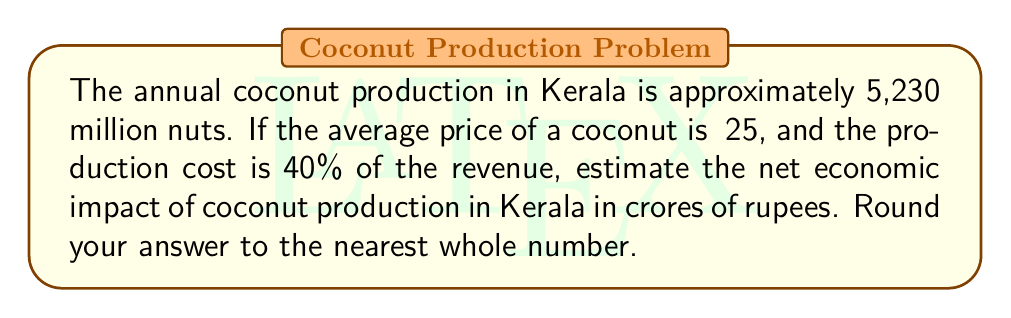Show me your answer to this math problem. Let's approach this problem step-by-step:

1. Calculate the total revenue:
   - Number of coconuts = 5,230 million
   - Price per coconut = ₹25
   - Total revenue = $5,230,000,000 \times ₹25 = ₹130,750,000,000$

2. Calculate the production cost:
   - Production cost is 40% of revenue
   - Production cost = $0.40 \times ₹130,750,000,000 = ₹52,300,000,000$

3. Calculate the net economic impact:
   - Net impact = Total revenue - Production cost
   - Net impact = $₹130,750,000,000 - ₹52,300,000,000 = ₹78,450,000,000$

4. Convert to crores:
   - 1 crore = 10,000,000
   - Net impact in crores = $\frac{₹78,450,000,000}{10,000,000} = 7,845$ crores

5. Round to the nearest whole number:
   - 7,845 crores (already a whole number)

Therefore, the estimated net economic impact of coconut production in Kerala is 7,845 crores of rupees.
Answer: 7,845 crores 